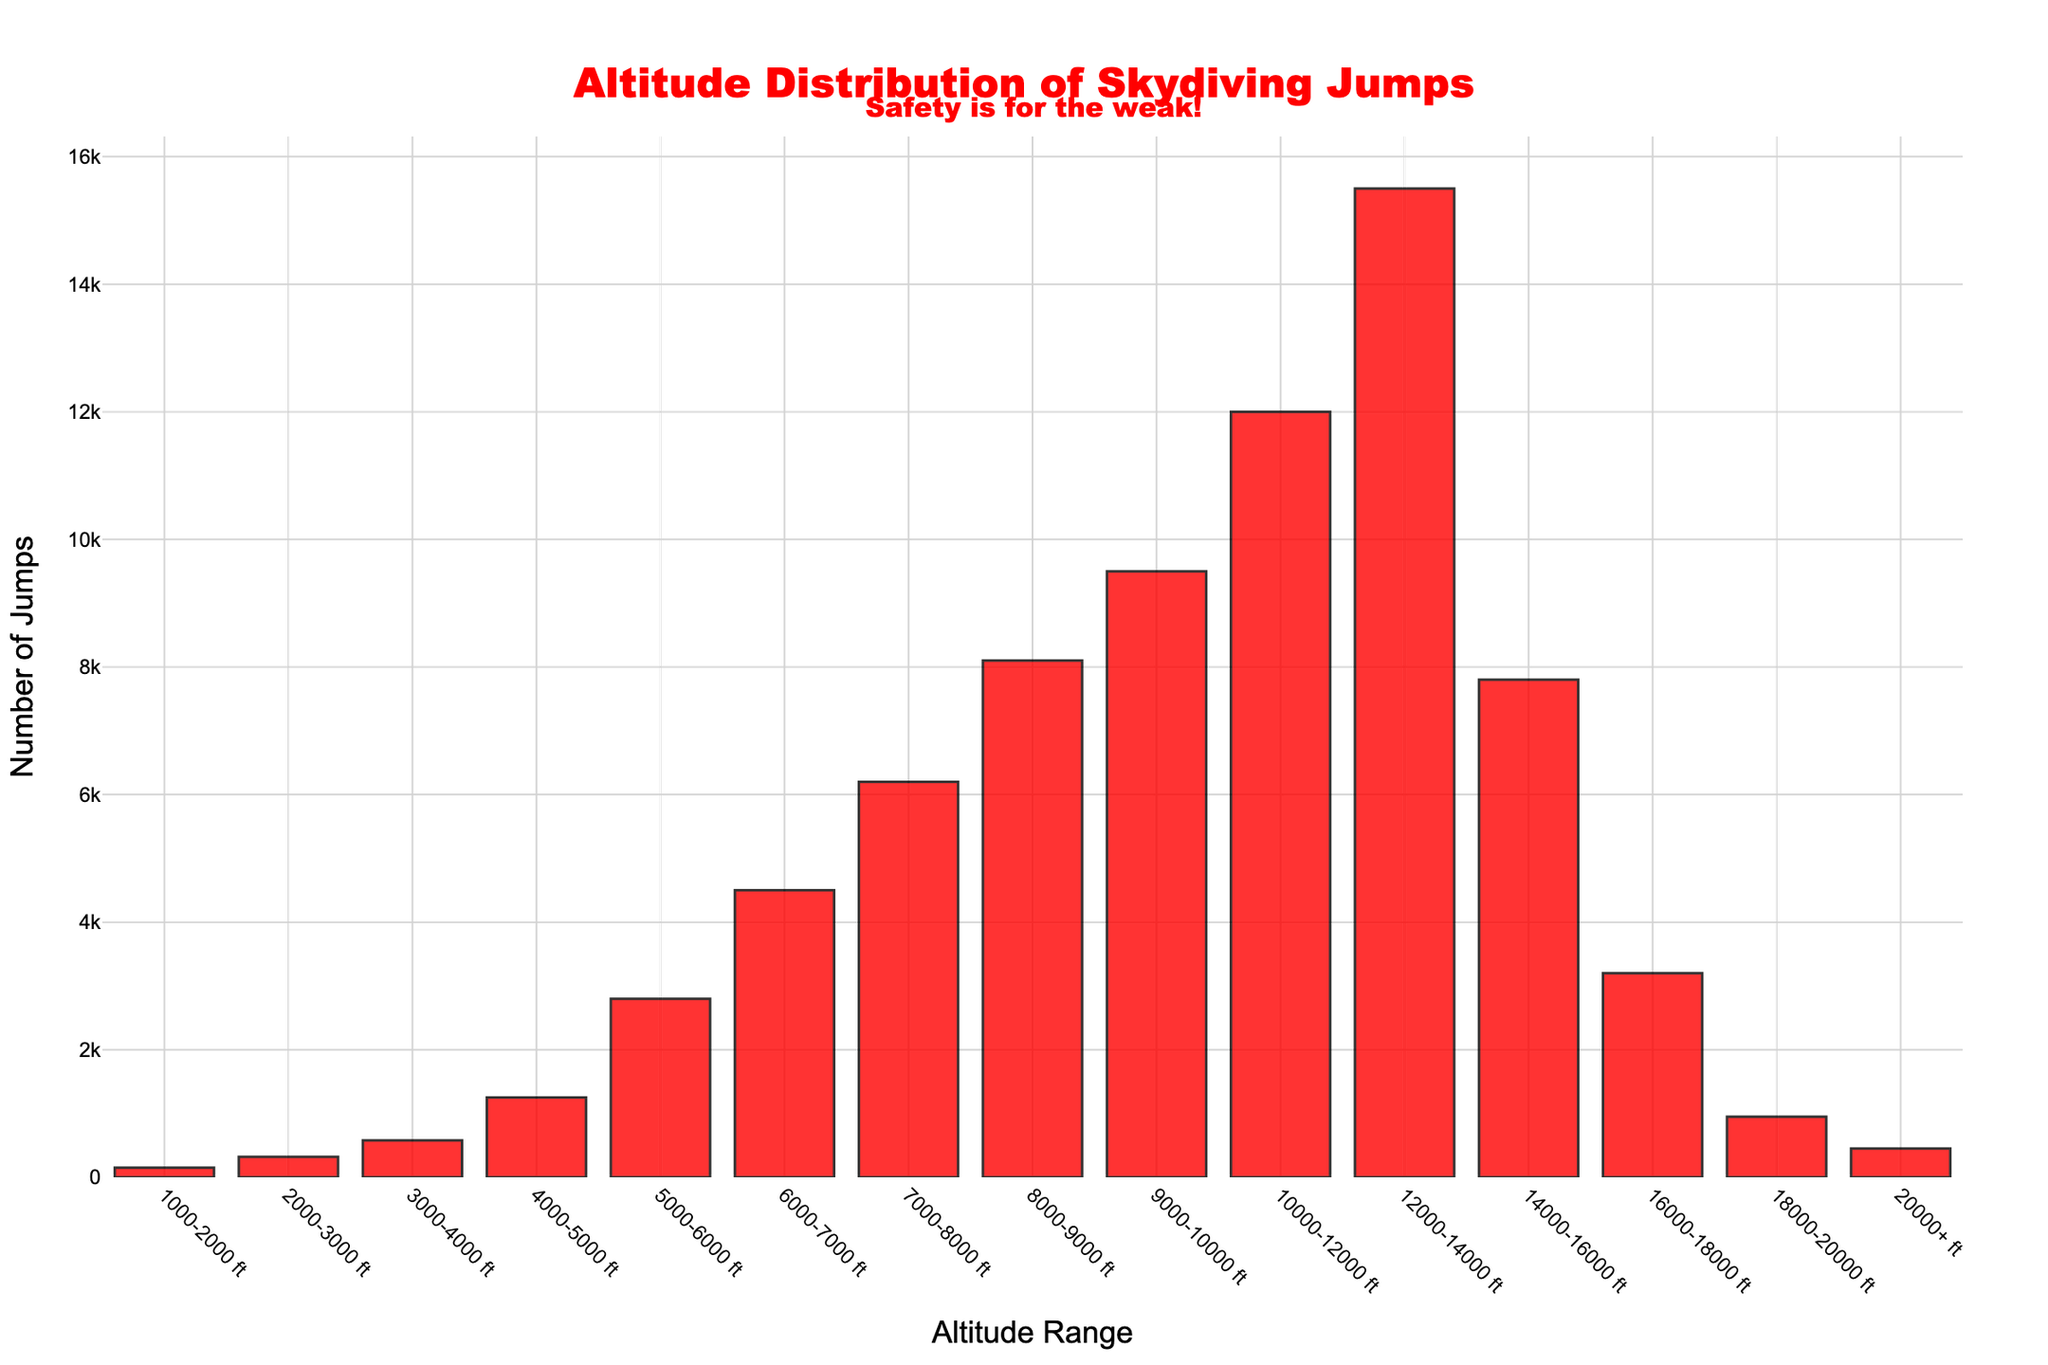How many skydiving jumps were performed between 10,000 and 12,000 feet? Look at the bar labeled "10000-12000 ft" and read the corresponding number of jumps, which is 12,000.
Answer: 12,000 What is the total number of jumps performed above 16,000 feet? Add the values for the altitude ranges "16000-18000 ft," "18000-20000 ft," and "20000+ ft": 3200 + 950 + 450 = 4,600.
Answer: 4,600 Which altitude range has the highest number of jumps? Find the tallest bar, which corresponds to the "12000-14000 ft" range at 15,500 jumps.
Answer: 12000-14000 ft How many more jumps are performed at 6000-7000 feet compared to 16000-18000 feet? Subtract the number of jumps at "16000-18000 ft" from the number at "6000-7000 ft": 4500 - 3200 = 1,300.
Answer: 1,300 What is the average number of jumps for the altitude ranges between 1000 and 8000 feet? Add the jumps for "1000-2000 ft," "2000-3000 ft," "3000-4000 ft," "4000-5000 ft," "5000-6000 ft," "6000-7000 ft," and "7000-8000 ft," then divide by 7: (150 + 320 + 580 + 1250 + 2800 + 4500 + 6200)/7 ≈ 2286.43.
Answer: 2286.43 What is the combined number of jumps for the altitude ranges that are under 4000 feet? Add the values for "1000-2000 ft," "2000-3000 ft," and "3000-4000 ft": 150 + 320 + 580 = 1,050.
Answer: 1,050 How does the number of jumps at 20000+ feet compare to the number of jumps at 18000-20000 feet? Compare the heights of the bars; "20000+ ft" has 450 jumps, while "18000-20000 ft" has 950 jumps. Therefore, "20000+ ft" has fewer jumps.
Answer: Fewer Which altitude range has the lowest number of jumps? Find the shortest bar, which corresponds to the "1000-2000 ft" range with 150 jumps.
Answer: 1000-2000 ft What is the percentage of jumps performed at altitudes higher than 14000 feet, out of the total number of jumps? Calculate the total jumps (sum of all bars), then find the sum of jumps for "14000-16000 ft," "16000-18000 ft," "18000-20000 ft," and "20000+ ft": Total jumps: 150 + 320 + 580 + 1250 + 2800 + 4500 + 6200 + 8100 + 9500 + 12000 + 15500 + 7800 + 3200 + 950 + 450 = 76,300. Higher than 14000 ft: 7800 + 3200 + 950 + 450 = 12,400. Percentage = (12400 / 76300) * 100 ≈ 16.24%.
Answer: 16.24% 